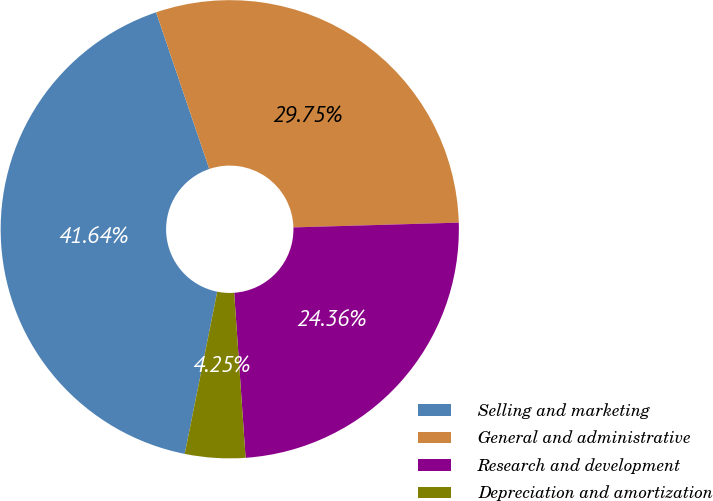<chart> <loc_0><loc_0><loc_500><loc_500><pie_chart><fcel>Selling and marketing<fcel>General and administrative<fcel>Research and development<fcel>Depreciation and amortization<nl><fcel>41.64%<fcel>29.75%<fcel>24.36%<fcel>4.25%<nl></chart> 